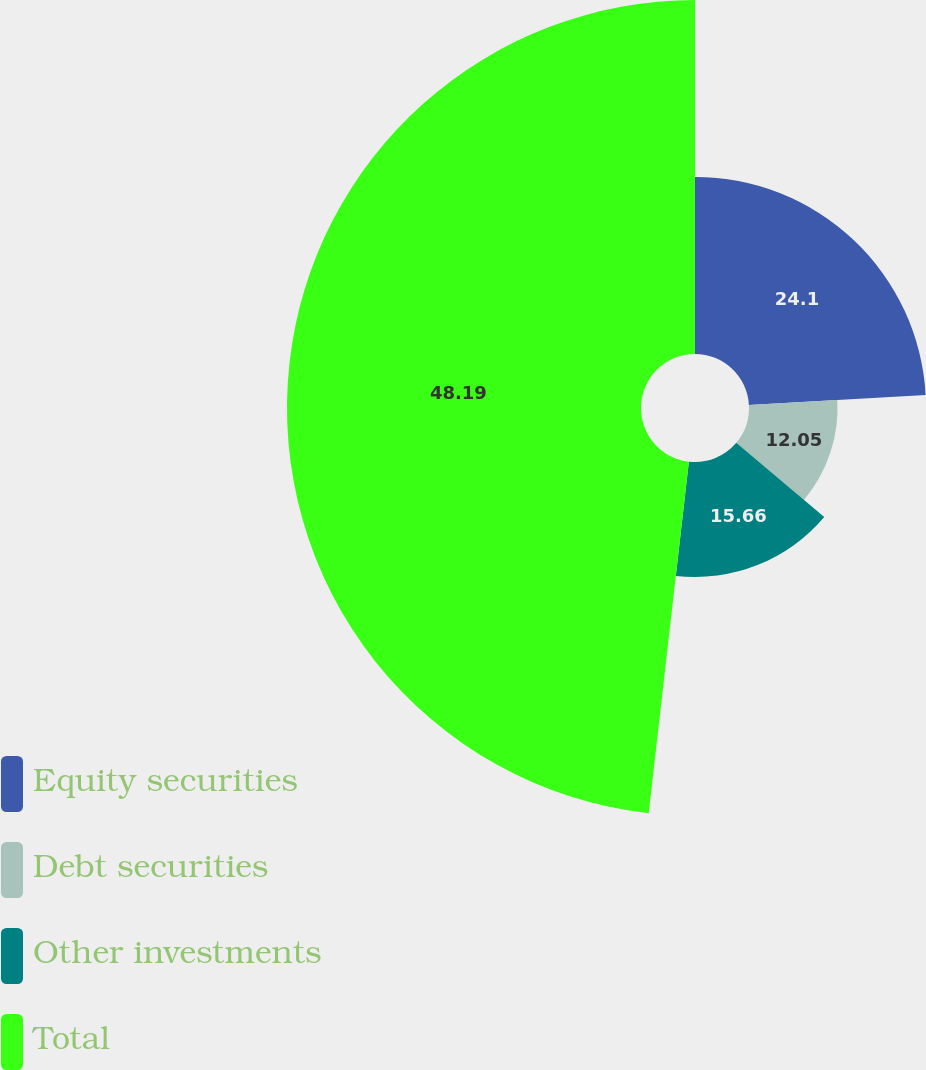<chart> <loc_0><loc_0><loc_500><loc_500><pie_chart><fcel>Equity securities<fcel>Debt securities<fcel>Other investments<fcel>Total<nl><fcel>24.1%<fcel>12.05%<fcel>15.66%<fcel>48.19%<nl></chart> 